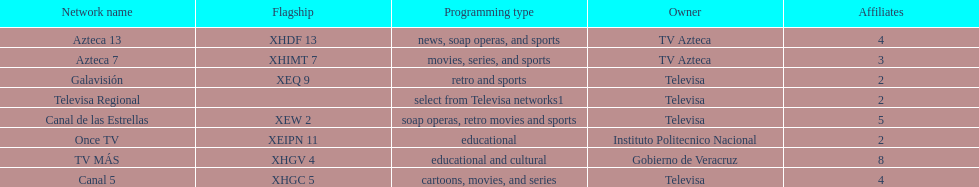What is the number of affiliates of canal de las estrellas. 5. 